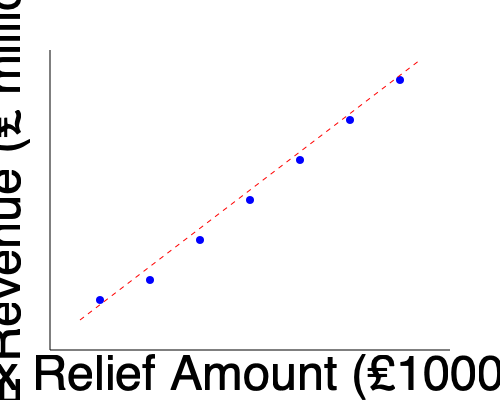Based on the scatter plot showing the relationship between SME revenue and tax relief amounts, what can be inferred about the correlation between these two variables? How might this information be used to guide tax policy for small and medium-sized enterprises? To analyze the correlation between SME revenue and tax relief amounts based on the scatter plot, we should follow these steps:

1. Observe the overall trend:
   The points in the scatter plot form a pattern moving from the bottom-left to the top-right of the graph.

2. Identify the direction of the relationship:
   As the tax relief amount increases (x-axis), the SME revenue (y-axis) tends to decrease.

3. Assess the strength of the relationship:
   The points fall relatively close to the trend line (red dashed line), indicating a strong correlation.

4. Determine the type of correlation:
   The relationship appears to be negative (inverse) as one variable increases while the other decreases.

5. Quantify the correlation:
   While we can't calculate an exact correlation coefficient without the raw data, visually we can estimate it to be around -0.9 to -0.95, indicating a strong negative correlation.

6. Interpret the results:
   SMEs receiving higher tax relief amounts tend to have lower revenues, and vice versa. This could suggest that tax relief is effectively targeted at smaller businesses or those facing financial challenges.

7. Consider policy implications:
   - The strong correlation supports the current tax relief system's effectiveness in targeting SMEs based on their revenue.
   - Policymakers might consider maintaining or expanding the current tax relief program, as it appears to be reaching the intended businesses.
   - Further investigation into causality is needed to determine if tax relief leads to increased revenue over time, which isn't captured in this cross-sectional data.
   - The policy could be refined to provide stepped relief amounts to smooth the transition as SMEs grow and potentially "graduate" from needing as much support.

8. Limitations:
   - Correlation does not imply causation. Other factors may influence both revenue and tax relief eligibility.
   - The scatter plot doesn't show changes over time, which could provide valuable insights into the long-term effects of tax relief on SME growth.
Answer: Strong negative correlation between tax relief and SME revenue, suggesting effective targeting of relief to smaller or struggling businesses. Policy implications include maintaining or refining the current system while investigating long-term impacts and causality. 